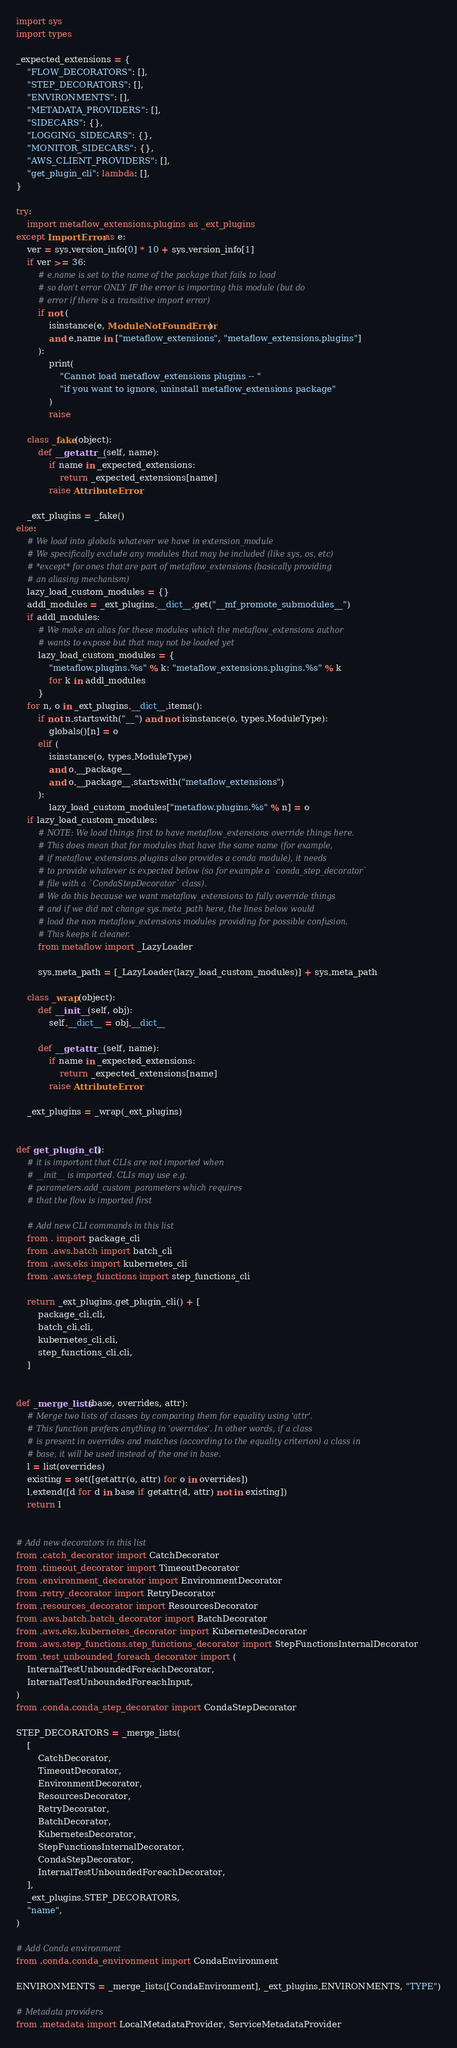<code> <loc_0><loc_0><loc_500><loc_500><_Python_>import sys
import types

_expected_extensions = {
    "FLOW_DECORATORS": [],
    "STEP_DECORATORS": [],
    "ENVIRONMENTS": [],
    "METADATA_PROVIDERS": [],
    "SIDECARS": {},
    "LOGGING_SIDECARS": {},
    "MONITOR_SIDECARS": {},
    "AWS_CLIENT_PROVIDERS": [],
    "get_plugin_cli": lambda: [],
}

try:
    import metaflow_extensions.plugins as _ext_plugins
except ImportError as e:
    ver = sys.version_info[0] * 10 + sys.version_info[1]
    if ver >= 36:
        # e.name is set to the name of the package that fails to load
        # so don't error ONLY IF the error is importing this module (but do
        # error if there is a transitive import error)
        if not (
            isinstance(e, ModuleNotFoundError)
            and e.name in ["metaflow_extensions", "metaflow_extensions.plugins"]
        ):
            print(
                "Cannot load metaflow_extensions plugins -- "
                "if you want to ignore, uninstall metaflow_extensions package"
            )
            raise

    class _fake(object):
        def __getattr__(self, name):
            if name in _expected_extensions:
                return _expected_extensions[name]
            raise AttributeError

    _ext_plugins = _fake()
else:
    # We load into globals whatever we have in extension_module
    # We specifically exclude any modules that may be included (like sys, os, etc)
    # *except* for ones that are part of metaflow_extensions (basically providing
    # an aliasing mechanism)
    lazy_load_custom_modules = {}
    addl_modules = _ext_plugins.__dict__.get("__mf_promote_submodules__")
    if addl_modules:
        # We make an alias for these modules which the metaflow_extensions author
        # wants to expose but that may not be loaded yet
        lazy_load_custom_modules = {
            "metaflow.plugins.%s" % k: "metaflow_extensions.plugins.%s" % k
            for k in addl_modules
        }
    for n, o in _ext_plugins.__dict__.items():
        if not n.startswith("__") and not isinstance(o, types.ModuleType):
            globals()[n] = o
        elif (
            isinstance(o, types.ModuleType)
            and o.__package__
            and o.__package__.startswith("metaflow_extensions")
        ):
            lazy_load_custom_modules["metaflow.plugins.%s" % n] = o
    if lazy_load_custom_modules:
        # NOTE: We load things first to have metaflow_extensions override things here.
        # This does mean that for modules that have the same name (for example,
        # if metaflow_extensions.plugins also provides a conda module), it needs
        # to provide whatever is expected below (so for example a `conda_step_decorator`
        # file with a `CondaStepDecorator` class).
        # We do this because we want metaflow_extensions to fully override things
        # and if we did not change sys.meta_path here, the lines below would
        # load the non metaflow_extensions modules providing for possible confusion.
        # This keeps it cleaner.
        from metaflow import _LazyLoader

        sys.meta_path = [_LazyLoader(lazy_load_custom_modules)] + sys.meta_path

    class _wrap(object):
        def __init__(self, obj):
            self.__dict__ = obj.__dict__

        def __getattr__(self, name):
            if name in _expected_extensions:
                return _expected_extensions[name]
            raise AttributeError

    _ext_plugins = _wrap(_ext_plugins)


def get_plugin_cli():
    # it is important that CLIs are not imported when
    # __init__ is imported. CLIs may use e.g.
    # parameters.add_custom_parameters which requires
    # that the flow is imported first

    # Add new CLI commands in this list
    from . import package_cli
    from .aws.batch import batch_cli
    from .aws.eks import kubernetes_cli
    from .aws.step_functions import step_functions_cli

    return _ext_plugins.get_plugin_cli() + [
        package_cli.cli,
        batch_cli.cli,
        kubernetes_cli.cli,
        step_functions_cli.cli,
    ]


def _merge_lists(base, overrides, attr):
    # Merge two lists of classes by comparing them for equality using 'attr'.
    # This function prefers anything in 'overrides'. In other words, if a class
    # is present in overrides and matches (according to the equality criterion) a class in
    # base, it will be used instead of the one in base.
    l = list(overrides)
    existing = set([getattr(o, attr) for o in overrides])
    l.extend([d for d in base if getattr(d, attr) not in existing])
    return l


# Add new decorators in this list
from .catch_decorator import CatchDecorator
from .timeout_decorator import TimeoutDecorator
from .environment_decorator import EnvironmentDecorator
from .retry_decorator import RetryDecorator
from .resources_decorator import ResourcesDecorator
from .aws.batch.batch_decorator import BatchDecorator
from .aws.eks.kubernetes_decorator import KubernetesDecorator
from .aws.step_functions.step_functions_decorator import StepFunctionsInternalDecorator
from .test_unbounded_foreach_decorator import (
    InternalTestUnboundedForeachDecorator,
    InternalTestUnboundedForeachInput,
)
from .conda.conda_step_decorator import CondaStepDecorator

STEP_DECORATORS = _merge_lists(
    [
        CatchDecorator,
        TimeoutDecorator,
        EnvironmentDecorator,
        ResourcesDecorator,
        RetryDecorator,
        BatchDecorator,
        KubernetesDecorator,
        StepFunctionsInternalDecorator,
        CondaStepDecorator,
        InternalTestUnboundedForeachDecorator,
    ],
    _ext_plugins.STEP_DECORATORS,
    "name",
)

# Add Conda environment
from .conda.conda_environment import CondaEnvironment

ENVIRONMENTS = _merge_lists([CondaEnvironment], _ext_plugins.ENVIRONMENTS, "TYPE")

# Metadata providers
from .metadata import LocalMetadataProvider, ServiceMetadataProvider
</code> 